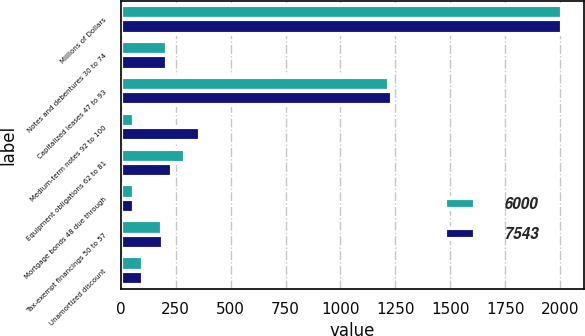Convert chart. <chart><loc_0><loc_0><loc_500><loc_500><stacked_bar_chart><ecel><fcel>Millions of Dollars<fcel>Notes and debentures 30 to 74<fcel>Capitalized leases 47 to 93<fcel>Medium-term notes 92 to 100<fcel>Equipment obligations 62 to 81<fcel>Mortgage bonds 48 due through<fcel>Tax-exempt financings 50 to 57<fcel>Unamortized discount<nl><fcel>6000<fcel>2007<fcel>211.5<fcel>1219<fcel>61<fcel>291<fcel>59<fcel>188<fcel>104<nl><fcel>7543<fcel>2006<fcel>211.5<fcel>1236<fcel>362<fcel>232<fcel>59<fcel>191<fcel>103<nl></chart> 